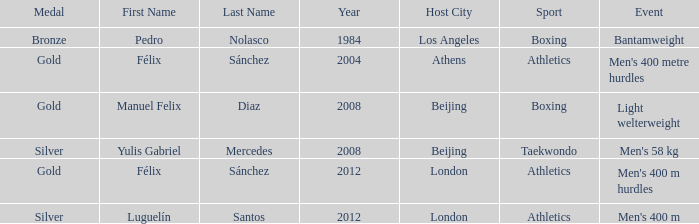Which Sport had an Event of men's 400 m hurdles? Athletics. 